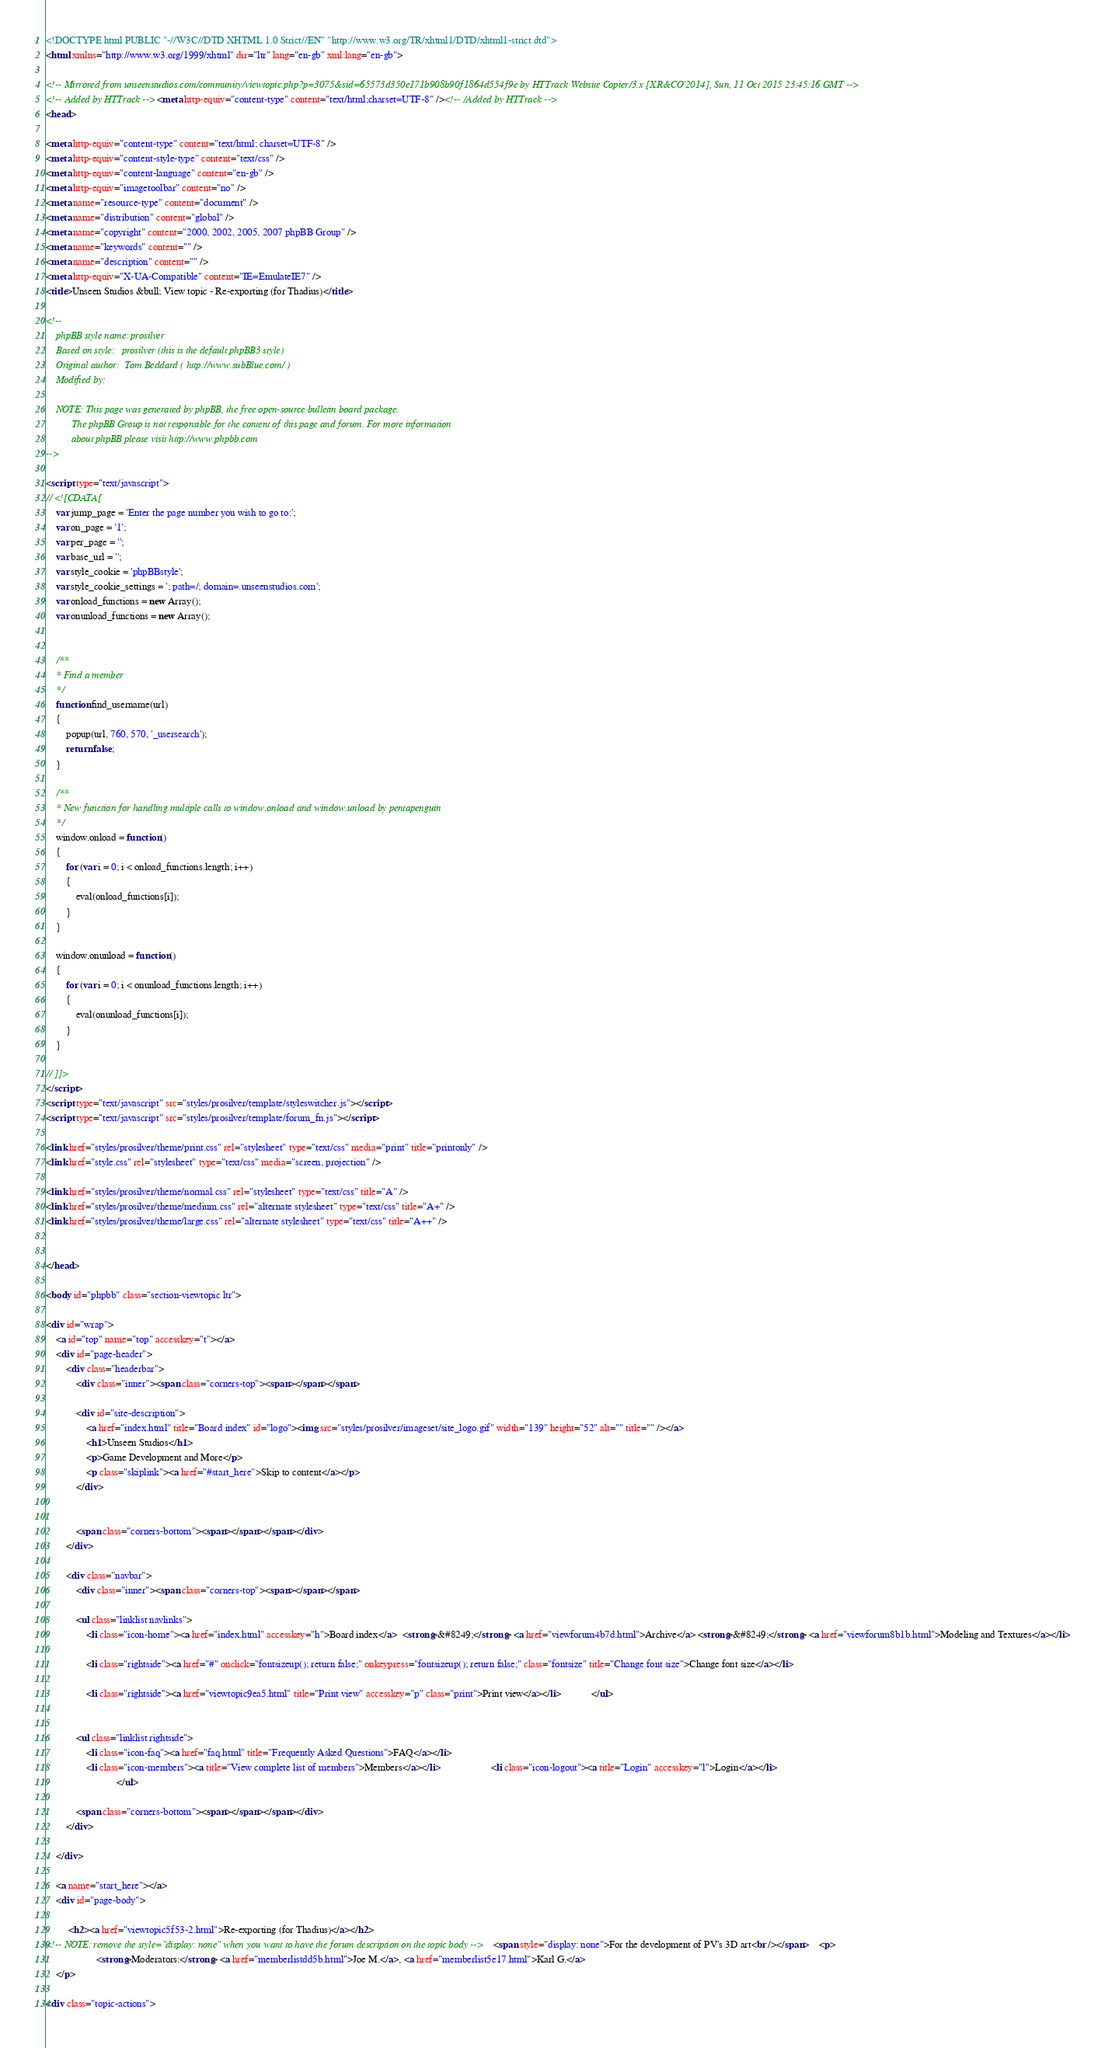<code> <loc_0><loc_0><loc_500><loc_500><_HTML_><!DOCTYPE html PUBLIC "-//W3C//DTD XHTML 1.0 Strict//EN" "http://www.w3.org/TR/xhtml1/DTD/xhtml1-strict.dtd">
<html xmlns="http://www.w3.org/1999/xhtml" dir="ltr" lang="en-gb" xml:lang="en-gb">

<!-- Mirrored from unseenstudios.com/community/viewtopic.php?p=3075&sid=65573d350e171b908b90f1864d554f9e by HTTrack Website Copier/3.x [XR&CO'2014], Sun, 11 Oct 2015 23:45:16 GMT -->
<!-- Added by HTTrack --><meta http-equiv="content-type" content="text/html;charset=UTF-8" /><!-- /Added by HTTrack -->
<head>

<meta http-equiv="content-type" content="text/html; charset=UTF-8" />
<meta http-equiv="content-style-type" content="text/css" />
<meta http-equiv="content-language" content="en-gb" />
<meta http-equiv="imagetoolbar" content="no" />
<meta name="resource-type" content="document" />
<meta name="distribution" content="global" />
<meta name="copyright" content="2000, 2002, 2005, 2007 phpBB Group" />
<meta name="keywords" content="" />
<meta name="description" content="" />
<meta http-equiv="X-UA-Compatible" content="IE=EmulateIE7" />
<title>Unseen Studios &bull; View topic - Re-exporting (for Thadius)</title>

<!--
	phpBB style name: prosilver
	Based on style:   prosilver (this is the default phpBB3 style)
	Original author:  Tom Beddard ( http://www.subBlue.com/ )
	Modified by:      
	
	NOTE: This page was generated by phpBB, the free open-source bulletin board package.
	      The phpBB Group is not responsible for the content of this page and forum. For more information
	      about phpBB please visit http://www.phpbb.com
-->

<script type="text/javascript">
// <![CDATA[
	var jump_page = 'Enter the page number you wish to go to:';
	var on_page = '1';
	var per_page = '';
	var base_url = '';
	var style_cookie = 'phpBBstyle';
	var style_cookie_settings = '; path=/; domain=.unseenstudios.com';
	var onload_functions = new Array();
	var onunload_functions = new Array();

	
	/**
	* Find a member
	*/
	function find_username(url)
	{
		popup(url, 760, 570, '_usersearch');
		return false;
	}

	/**
	* New function for handling multiple calls to window.onload and window.unload by pentapenguin
	*/
	window.onload = function()
	{
		for (var i = 0; i < onload_functions.length; i++)
		{
			eval(onload_functions[i]);
		}
	}

	window.onunload = function()
	{
		for (var i = 0; i < onunload_functions.length; i++)
		{
			eval(onunload_functions[i]);
		}
	}

// ]]>
</script>
<script type="text/javascript" src="styles/prosilver/template/styleswitcher.js"></script>
<script type="text/javascript" src="styles/prosilver/template/forum_fn.js"></script>

<link href="styles/prosilver/theme/print.css" rel="stylesheet" type="text/css" media="print" title="printonly" />
<link href="style.css" rel="stylesheet" type="text/css" media="screen, projection" />

<link href="styles/prosilver/theme/normal.css" rel="stylesheet" type="text/css" title="A" />
<link href="styles/prosilver/theme/medium.css" rel="alternate stylesheet" type="text/css" title="A+" />
<link href="styles/prosilver/theme/large.css" rel="alternate stylesheet" type="text/css" title="A++" />


</head>

<body id="phpbb" class="section-viewtopic ltr">

<div id="wrap">
	<a id="top" name="top" accesskey="t"></a>
	<div id="page-header">
		<div class="headerbar">
			<div class="inner"><span class="corners-top"><span></span></span>

			<div id="site-description">
				<a href="index.html" title="Board index" id="logo"><img src="styles/prosilver/imageset/site_logo.gif" width="139" height="52" alt="" title="" /></a>
				<h1>Unseen Studios</h1>
				<p>Game Development and More</p>
				<p class="skiplink"><a href="#start_here">Skip to content</a></p>
			</div>

		
			<span class="corners-bottom"><span></span></span></div>
		</div>

		<div class="navbar">
			<div class="inner"><span class="corners-top"><span></span></span>

			<ul class="linklist navlinks">
				<li class="icon-home"><a href="index.html" accesskey="h">Board index</a>  <strong>&#8249;</strong> <a href="viewforum4b7d.html">Archive</a> <strong>&#8249;</strong> <a href="viewforum8b1b.html">Modeling and Textures</a></li>

				<li class="rightside"><a href="#" onclick="fontsizeup(); return false;" onkeypress="fontsizeup(); return false;" class="fontsize" title="Change font size">Change font size</a></li>

				<li class="rightside"><a href="viewtopic9ea5.html" title="Print view" accesskey="p" class="print">Print view</a></li>			</ul>

			
			<ul class="linklist rightside">
				<li class="icon-faq"><a href="faq.html" title="Frequently Asked Questions">FAQ</a></li>
				<li class="icon-members"><a title="View complete list of members">Members</a></li>					<li class="icon-logout"><a title="Login" accesskey="l">Login</a></li>
							</ul>

			<span class="corners-bottom"><span></span></span></div>
		</div>

	</div>

	<a name="start_here"></a>
	<div id="page-body">
		
		 <h2><a href="viewtopic5f53-2.html">Re-exporting (for Thadius)</a></h2>
<!-- NOTE: remove the style="display: none" when you want to have the forum description on the topic body --><span style="display: none">For the development of PV's 3D art<br /></span>	<p>
					<strong>Moderators:</strong> <a href="memberlistdd5b.html">Joe M.</a>, <a href="memberlist5e17.html">Karl G.</a>		
	</p>

<div class="topic-actions">
</code> 